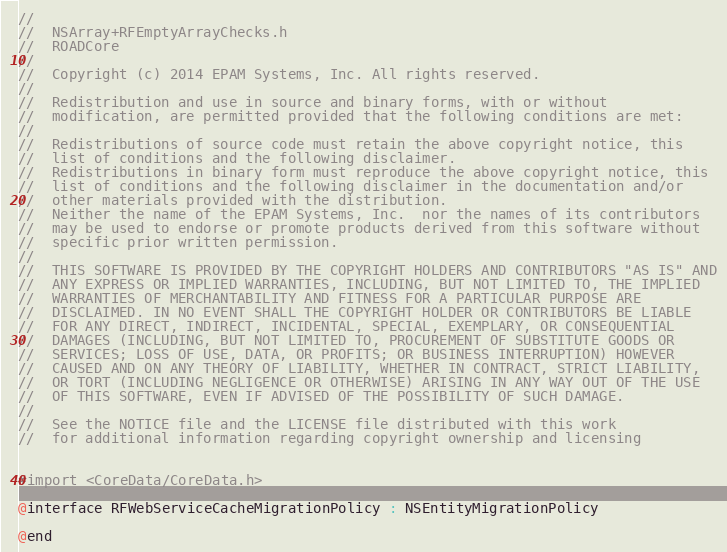<code> <loc_0><loc_0><loc_500><loc_500><_C_>//
//  NSArray+RFEmptyArrayChecks.h
//  ROADCore
//
//  Copyright (c) 2014 EPAM Systems, Inc. All rights reserved.
//
//  Redistribution and use in source and binary forms, with or without
//  modification, are permitted provided that the following conditions are met:
//
//  Redistributions of source code must retain the above copyright notice, this
//  list of conditions and the following disclaimer.
//  Redistributions in binary form must reproduce the above copyright notice, this
//  list of conditions and the following disclaimer in the documentation and/or
//  other materials provided with the distribution.
//  Neither the name of the EPAM Systems, Inc.  nor the names of its contributors
//  may be used to endorse or promote products derived from this software without
//  specific prior written permission.
//
//  THIS SOFTWARE IS PROVIDED BY THE COPYRIGHT HOLDERS AND CONTRIBUTORS "AS IS" AND
//  ANY EXPRESS OR IMPLIED WARRANTIES, INCLUDING, BUT NOT LIMITED TO, THE IMPLIED
//  WARRANTIES OF MERCHANTABILITY AND FITNESS FOR A PARTICULAR PURPOSE ARE
//  DISCLAIMED. IN NO EVENT SHALL THE COPYRIGHT HOLDER OR CONTRIBUTORS BE LIABLE
//  FOR ANY DIRECT, INDIRECT, INCIDENTAL, SPECIAL, EXEMPLARY, OR CONSEQUENTIAL
//  DAMAGES (INCLUDING, BUT NOT LIMITED TO, PROCUREMENT OF SUBSTITUTE GOODS OR
//  SERVICES; LOSS OF USE, DATA, OR PROFITS; OR BUSINESS INTERRUPTION) HOWEVER
//  CAUSED AND ON ANY THEORY OF LIABILITY, WHETHER IN CONTRACT, STRICT LIABILITY,
//  OR TORT (INCLUDING NEGLIGENCE OR OTHERWISE) ARISING IN ANY WAY OUT OF THE USE
//  OF THIS SOFTWARE, EVEN IF ADVISED OF THE POSSIBILITY OF SUCH DAMAGE.
//
//  See the NOTICE file and the LICENSE file distributed with this work
//  for additional information regarding copyright ownership and licensing


#import <CoreData/CoreData.h>

@interface RFWebServiceCacheMigrationPolicy : NSEntityMigrationPolicy

@end
</code> 